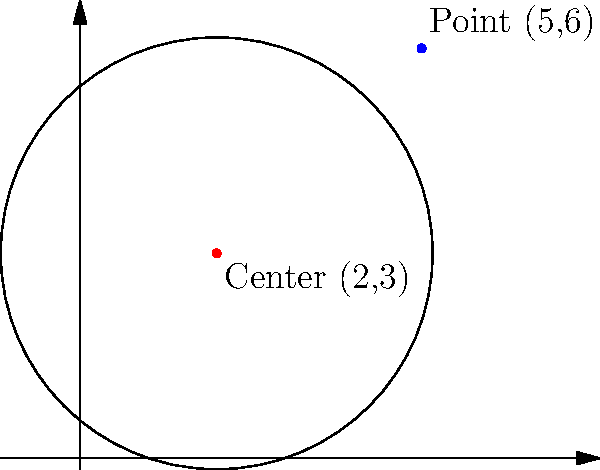As a backend developer working on a geometry-based feature, you need to determine the equation of a circle. Given that the center of the circle is at (2,3) and a point on its circumference is (5,6), what is the equation of this circle? To find the equation of a circle given its center and a point on its circumference, we can follow these steps:

1) The general equation of a circle is $$(x-h)^2 + (y-k)^2 = r^2$$
   where (h,k) is the center and r is the radius.

2) We're given the center (2,3), so h = 2 and k = 3.

3) To find r, we can calculate the distance between the center and the given point:
   $$r^2 = (x-h)^2 + (y-k)^2 = (5-2)^2 + (6-3)^2 = 3^2 + 3^2 = 18$$

4) Substituting these values into the general equation:
   $$(x-2)^2 + (y-3)^2 = 18$$

5) This is the equation of the circle in standard form.

6) If we expand this, we get:
   $$x^2 - 4x + 4 + y^2 - 6y + 9 = 18$$
   $$x^2 + y^2 - 4x - 6y - 5 = 0$$

This is the general form of the circle equation.
Answer: $(x-2)^2 + (y-3)^2 = 18$ or $x^2 + y^2 - 4x - 6y - 5 = 0$ 